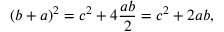Convert formula to latex. <formula><loc_0><loc_0><loc_500><loc_500>( b + a ) ^ { 2 } = c ^ { 2 } + 4 { \frac { a b } { 2 } } = c ^ { 2 } + 2 a b ,</formula> 